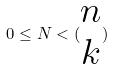Convert formula to latex. <formula><loc_0><loc_0><loc_500><loc_500>0 \leq N < ( \begin{matrix} n \\ k \end{matrix} )</formula> 